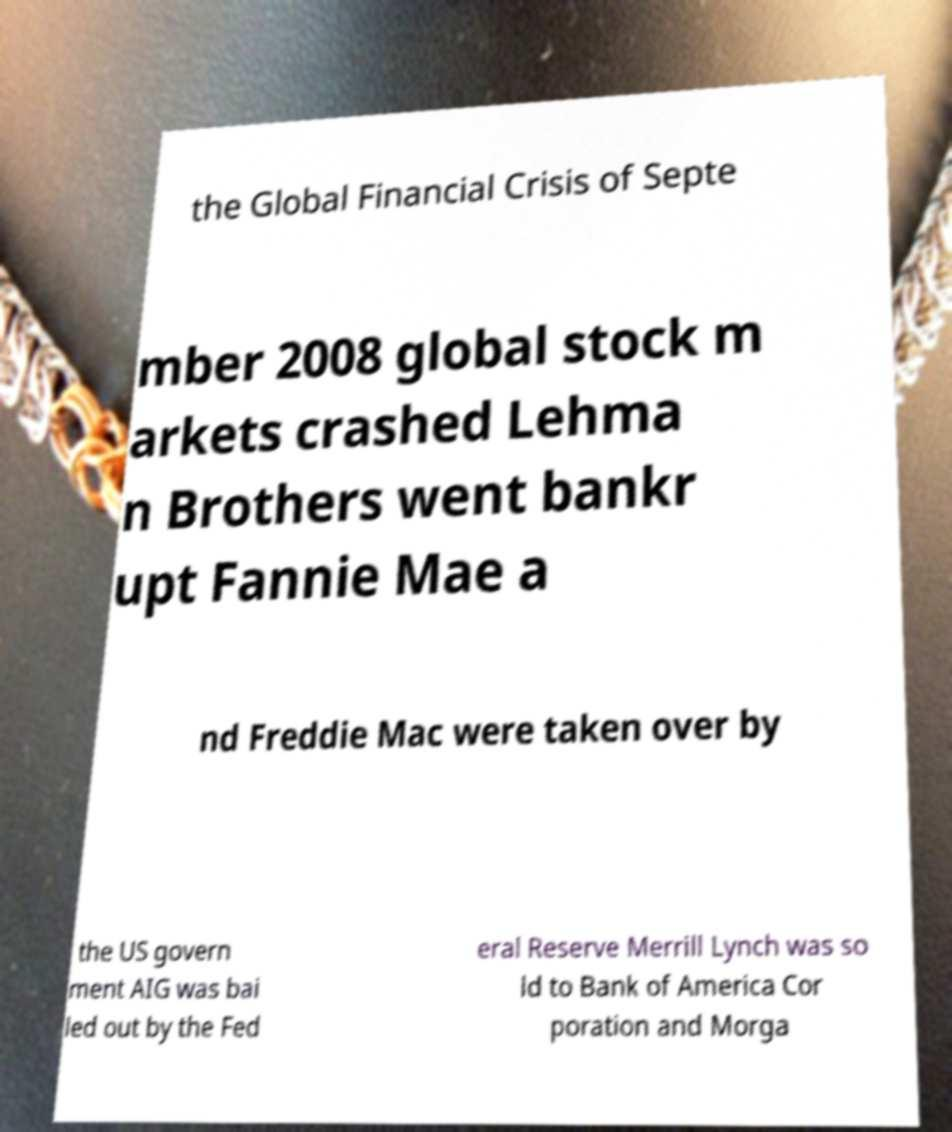Can you read and provide the text displayed in the image?This photo seems to have some interesting text. Can you extract and type it out for me? the Global Financial Crisis of Septe mber 2008 global stock m arkets crashed Lehma n Brothers went bankr upt Fannie Mae a nd Freddie Mac were taken over by the US govern ment AIG was bai led out by the Fed eral Reserve Merrill Lynch was so ld to Bank of America Cor poration and Morga 